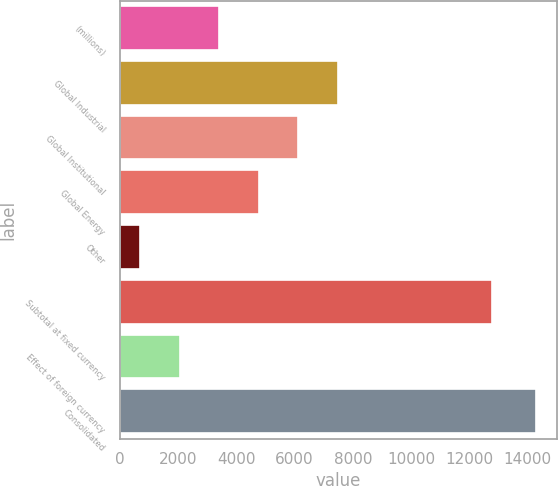Convert chart to OTSL. <chart><loc_0><loc_0><loc_500><loc_500><bar_chart><fcel>(millions)<fcel>Global Industrial<fcel>Global Institutional<fcel>Global Energy<fcel>Other<fcel>Subtotal at fixed currency<fcel>Effect of foreign currency<fcel>Consolidated<nl><fcel>3420.26<fcel>7492.85<fcel>6135.32<fcel>4777.79<fcel>705.2<fcel>12765.7<fcel>2062.73<fcel>14280.5<nl></chart> 